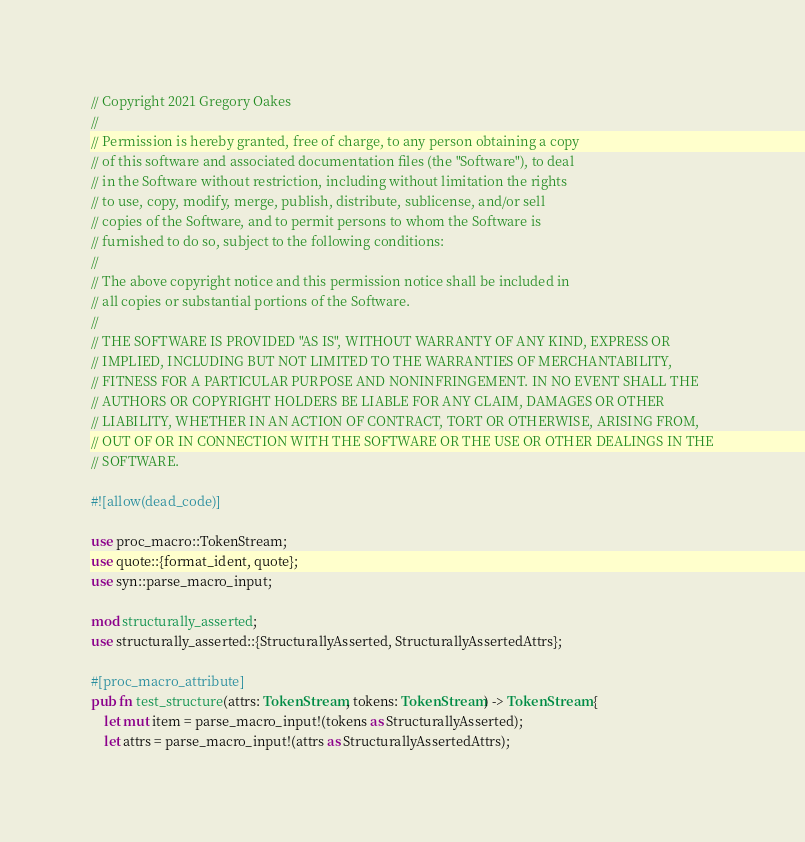<code> <loc_0><loc_0><loc_500><loc_500><_Rust_>// Copyright 2021 Gregory Oakes
//
// Permission is hereby granted, free of charge, to any person obtaining a copy
// of this software and associated documentation files (the "Software"), to deal
// in the Software without restriction, including without limitation the rights
// to use, copy, modify, merge, publish, distribute, sublicense, and/or sell
// copies of the Software, and to permit persons to whom the Software is
// furnished to do so, subject to the following conditions:
//
// The above copyright notice and this permission notice shall be included in
// all copies or substantial portions of the Software.
//
// THE SOFTWARE IS PROVIDED "AS IS", WITHOUT WARRANTY OF ANY KIND, EXPRESS OR
// IMPLIED, INCLUDING BUT NOT LIMITED TO THE WARRANTIES OF MERCHANTABILITY,
// FITNESS FOR A PARTICULAR PURPOSE AND NONINFRINGEMENT. IN NO EVENT SHALL THE
// AUTHORS OR COPYRIGHT HOLDERS BE LIABLE FOR ANY CLAIM, DAMAGES OR OTHER
// LIABILITY, WHETHER IN AN ACTION OF CONTRACT, TORT OR OTHERWISE, ARISING FROM,
// OUT OF OR IN CONNECTION WITH THE SOFTWARE OR THE USE OR OTHER DEALINGS IN THE
// SOFTWARE.

#![allow(dead_code)]

use proc_macro::TokenStream;
use quote::{format_ident, quote};
use syn::parse_macro_input;

mod structurally_asserted;
use structurally_asserted::{StructurallyAsserted, StructurallyAssertedAttrs};

#[proc_macro_attribute]
pub fn test_structure(attrs: TokenStream, tokens: TokenStream) -> TokenStream {
    let mut item = parse_macro_input!(tokens as StructurallyAsserted);
    let attrs = parse_macro_input!(attrs as StructurallyAssertedAttrs);</code> 